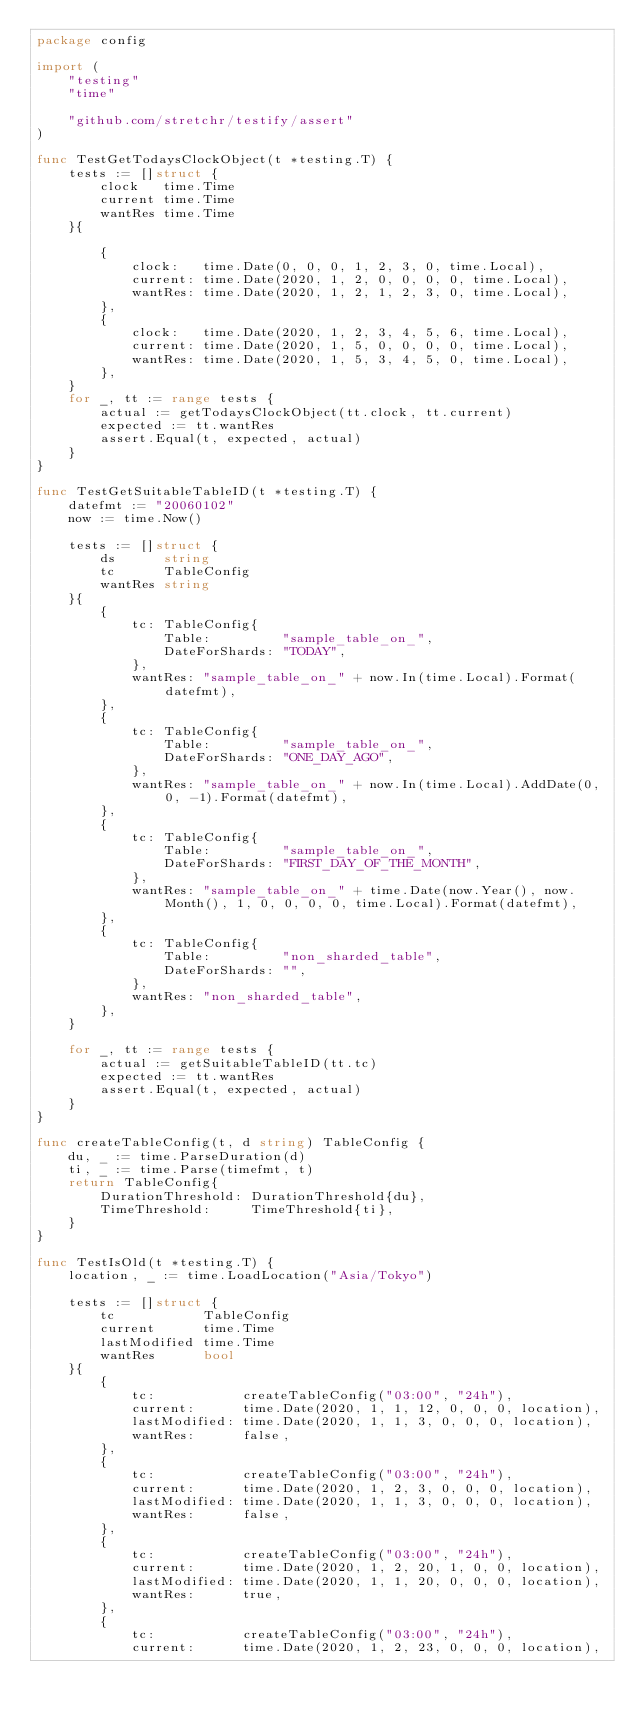Convert code to text. <code><loc_0><loc_0><loc_500><loc_500><_Go_>package config

import (
	"testing"
	"time"

	"github.com/stretchr/testify/assert"
)

func TestGetTodaysClockObject(t *testing.T) {
	tests := []struct {
		clock   time.Time
		current time.Time
		wantRes time.Time
	}{

		{
			clock:   time.Date(0, 0, 0, 1, 2, 3, 0, time.Local),
			current: time.Date(2020, 1, 2, 0, 0, 0, 0, time.Local),
			wantRes: time.Date(2020, 1, 2, 1, 2, 3, 0, time.Local),
		},
		{
			clock:   time.Date(2020, 1, 2, 3, 4, 5, 6, time.Local),
			current: time.Date(2020, 1, 5, 0, 0, 0, 0, time.Local),
			wantRes: time.Date(2020, 1, 5, 3, 4, 5, 0, time.Local),
		},
	}
	for _, tt := range tests {
		actual := getTodaysClockObject(tt.clock, tt.current)
		expected := tt.wantRes
		assert.Equal(t, expected, actual)
	}
}

func TestGetSuitableTableID(t *testing.T) {
	datefmt := "20060102"
	now := time.Now()

	tests := []struct {
		ds      string
		tc      TableConfig
		wantRes string
	}{
		{
			tc: TableConfig{
				Table:         "sample_table_on_",
				DateForShards: "TODAY",
			},
			wantRes: "sample_table_on_" + now.In(time.Local).Format(datefmt),
		},
		{
			tc: TableConfig{
				Table:         "sample_table_on_",
				DateForShards: "ONE_DAY_AGO",
			},
			wantRes: "sample_table_on_" + now.In(time.Local).AddDate(0, 0, -1).Format(datefmt),
		},
		{
			tc: TableConfig{
				Table:         "sample_table_on_",
				DateForShards: "FIRST_DAY_OF_THE_MONTH",
			},
			wantRes: "sample_table_on_" + time.Date(now.Year(), now.Month(), 1, 0, 0, 0, 0, time.Local).Format(datefmt),
		},
		{
			tc: TableConfig{
				Table:         "non_sharded_table",
				DateForShards: "",
			},
			wantRes: "non_sharded_table",
		},
	}

	for _, tt := range tests {
		actual := getSuitableTableID(tt.tc)
		expected := tt.wantRes
		assert.Equal(t, expected, actual)
	}
}

func createTableConfig(t, d string) TableConfig {
	du, _ := time.ParseDuration(d)
	ti, _ := time.Parse(timefmt, t)
	return TableConfig{
		DurationThreshold: DurationThreshold{du},
		TimeThreshold:     TimeThreshold{ti},
	}
}

func TestIsOld(t *testing.T) {
	location, _ := time.LoadLocation("Asia/Tokyo")

	tests := []struct {
		tc           TableConfig
		current      time.Time
		lastModified time.Time
		wantRes      bool
	}{
		{
			tc:           createTableConfig("03:00", "24h"),
			current:      time.Date(2020, 1, 1, 12, 0, 0, 0, location),
			lastModified: time.Date(2020, 1, 1, 3, 0, 0, 0, location),
			wantRes:      false,
		},
		{
			tc:           createTableConfig("03:00", "24h"),
			current:      time.Date(2020, 1, 2, 3, 0, 0, 0, location),
			lastModified: time.Date(2020, 1, 1, 3, 0, 0, 0, location),
			wantRes:      false,
		},
		{
			tc:           createTableConfig("03:00", "24h"),
			current:      time.Date(2020, 1, 2, 20, 1, 0, 0, location),
			lastModified: time.Date(2020, 1, 1, 20, 0, 0, 0, location),
			wantRes:      true,
		},
		{
			tc:           createTableConfig("03:00", "24h"),
			current:      time.Date(2020, 1, 2, 23, 0, 0, 0, location),</code> 